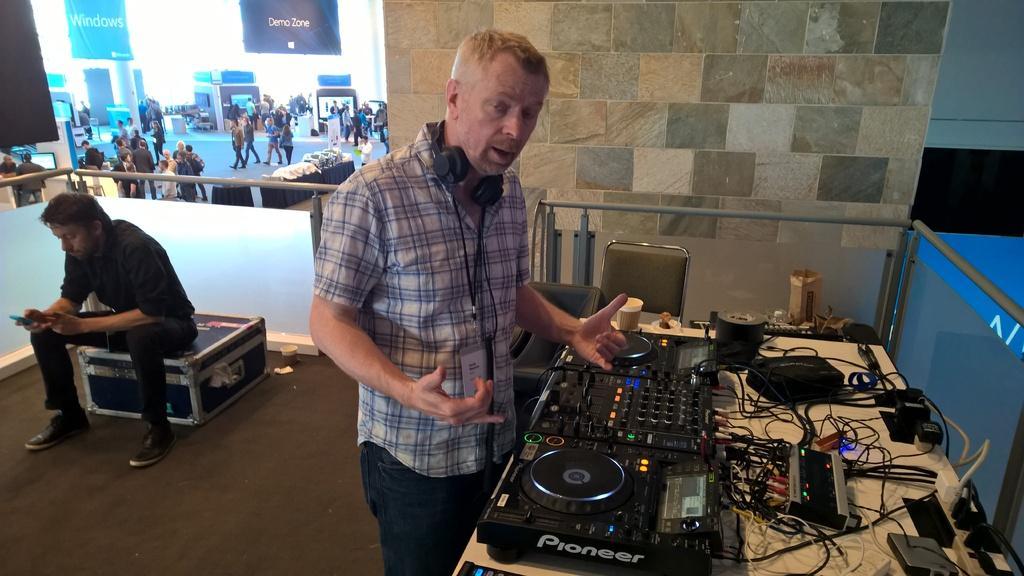Could you give a brief overview of what you see in this image? In this image we can see a group of people standing on the ground. One person is wearing a headphone and standing in front of a table. On the table we can see group devices and a cup placed on it. In the background, we can see a person sitting on a box, chairs placed on the ground, screens on the wall, pillars and banners with some text. 